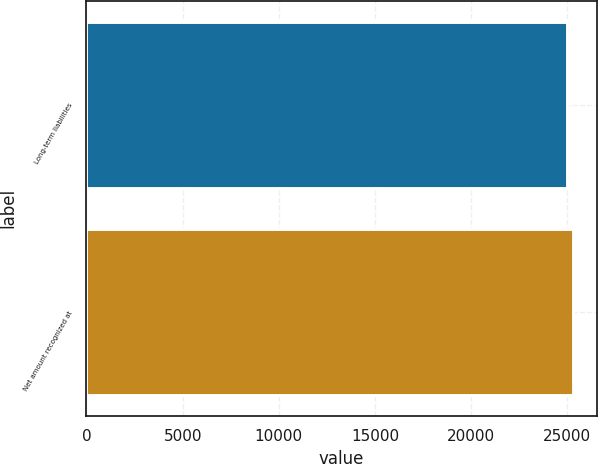Convert chart. <chart><loc_0><loc_0><loc_500><loc_500><bar_chart><fcel>Long-term liabilities<fcel>Net amount recognized at<nl><fcel>24980<fcel>25272<nl></chart> 